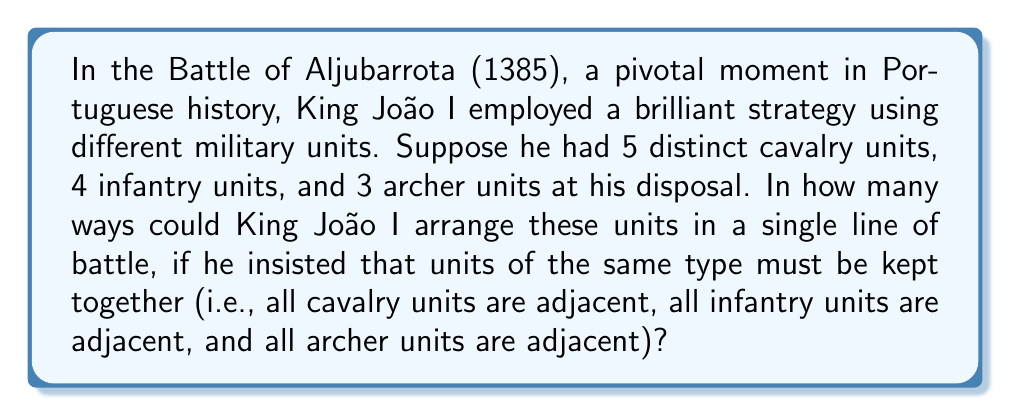Give your solution to this math problem. To solve this problem, we'll use the concept of permutation groups and the multiplication principle. Let's break it down step-by-step:

1) First, we need to consider the arrangement of the three types of units (cavalry, infantry, and archers) as a whole. This is a permutation of 3 elements, which can be arranged in $3! = 6$ ways.

2) Next, we need to consider the permutations within each type of unit:
   - Cavalry: 5 units can be arranged in $5!$ ways
   - Infantry: 4 units can be arranged in $4!$ ways
   - Archers: 3 units can be arranged in $3!$ ways

3) By the multiplication principle, the total number of possible arrangements is:

   $$3! \cdot 5! \cdot 4! \cdot 3!$$

4) Let's calculate this:
   $$3! \cdot 5! \cdot 4! \cdot 3! = 6 \cdot 120 \cdot 24 \cdot 6 = 103,680$$

This result represents the order of the permutation group for this problem, which is isomorphic to the direct product of the symmetric groups $S_3 \times S_5 \times S_4 \times S_3$.
Answer: There are 103,680 possible ways for King João I to arrange his military units in the Battle of Aljubarrota under the given conditions. 